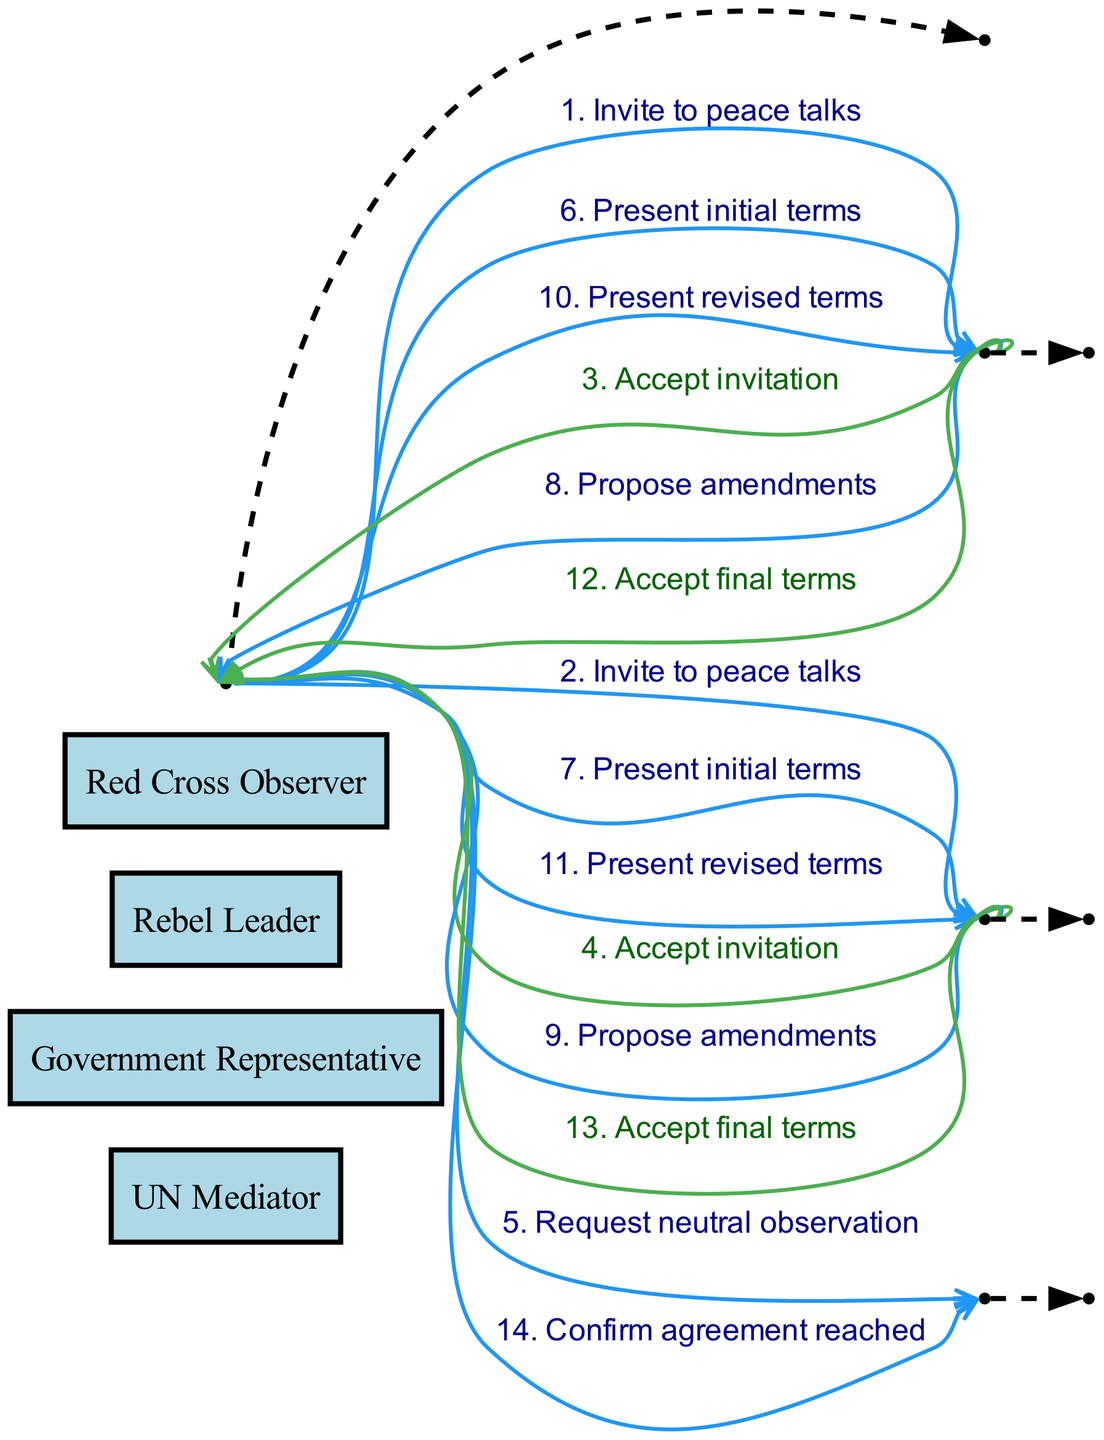What is the total number of actors involved in the peace negotiation? The diagram lists four actors: UN Mediator, Government Representative, Rebel Leader, and Red Cross Observer. Therefore, the total number of actors is four.
Answer: four Which actor was invited to peace talks first? The UN Mediator sent invitations to both the Government Representative and the Rebel Leader simultaneously. However, since both messages appear to be initiated by the UN Mediator at the same time, they are technically simultaneous. As for direct order, the Government Representative comes first in the sequence.
Answer: Government Representative How many times does the UN Mediator present terms to an actor? The UN Mediator presents initial terms and then revised terms, making a total of two presentations to each of the Government Representative and the Rebel Leader, which is four in total.
Answer: four What message did the Government Representative send to the UN Mediator after accepting the invitation? After accepting the invitation, the Government Representative proposed amendments to the UN Mediator. This shows their active participation in the negotiation process.
Answer: Propose amendments Which actor confirms the agreement reached at the end of the negotiation? The UN Mediator confirms the agreement reached by sending a message to the Red Cross Observer, indicating that the agreed terms have been finalized.
Answer: UN Mediator 